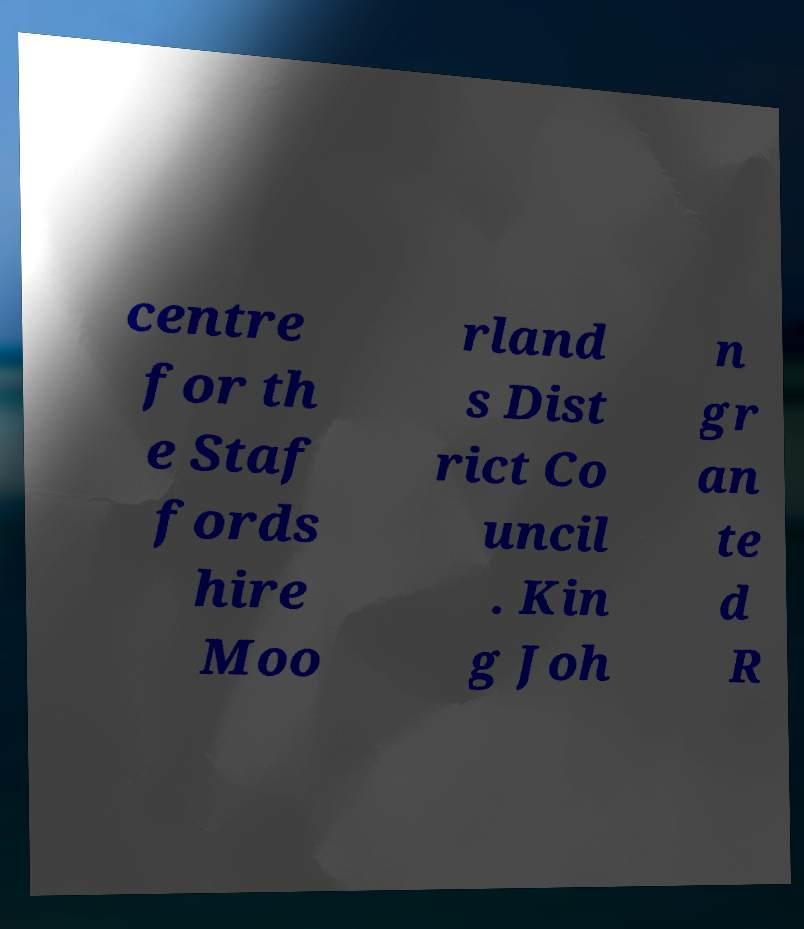Can you accurately transcribe the text from the provided image for me? centre for th e Staf fords hire Moo rland s Dist rict Co uncil . Kin g Joh n gr an te d R 